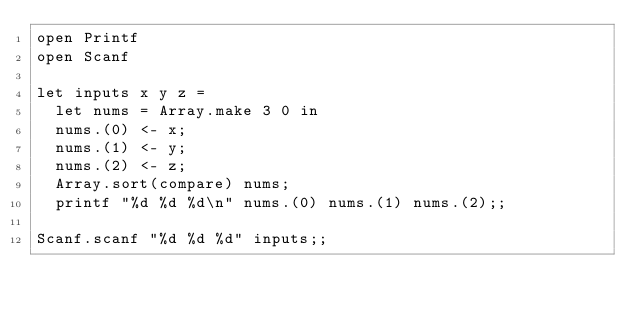<code> <loc_0><loc_0><loc_500><loc_500><_OCaml_>open Printf
open Scanf

let inputs x y z =
	let nums = Array.make 3 0 in
	nums.(0) <- x;
	nums.(1) <- y;
	nums.(2) <- z;
	Array.sort(compare) nums;
	printf "%d %d %d\n" nums.(0) nums.(1) nums.(2);;

Scanf.scanf "%d %d %d" inputs;;</code> 